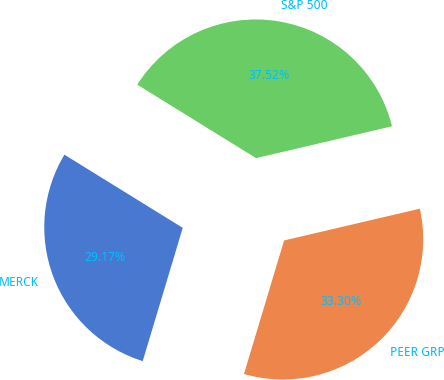<chart> <loc_0><loc_0><loc_500><loc_500><pie_chart><fcel>MERCK<fcel>PEER GRP<fcel>S&P 500<nl><fcel>29.17%<fcel>33.3%<fcel>37.52%<nl></chart> 